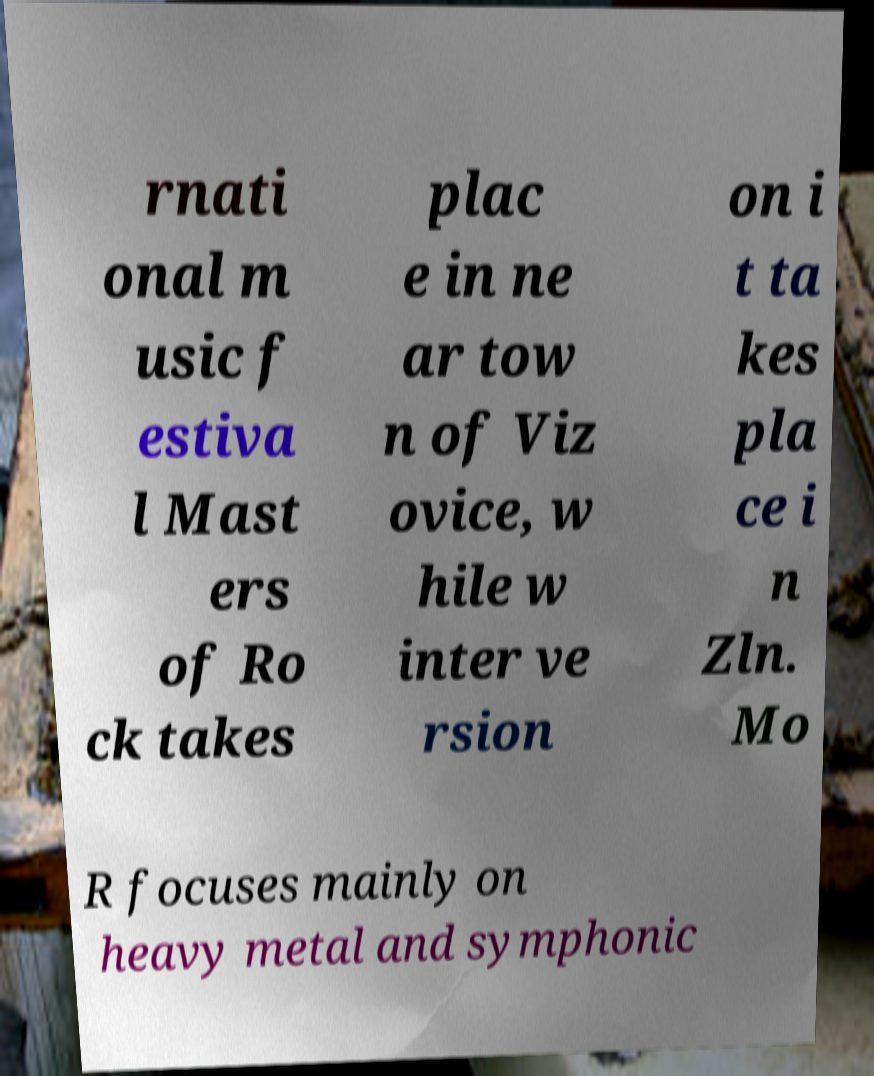Please read and relay the text visible in this image. What does it say? rnati onal m usic f estiva l Mast ers of Ro ck takes plac e in ne ar tow n of Viz ovice, w hile w inter ve rsion on i t ta kes pla ce i n Zln. Mo R focuses mainly on heavy metal and symphonic 